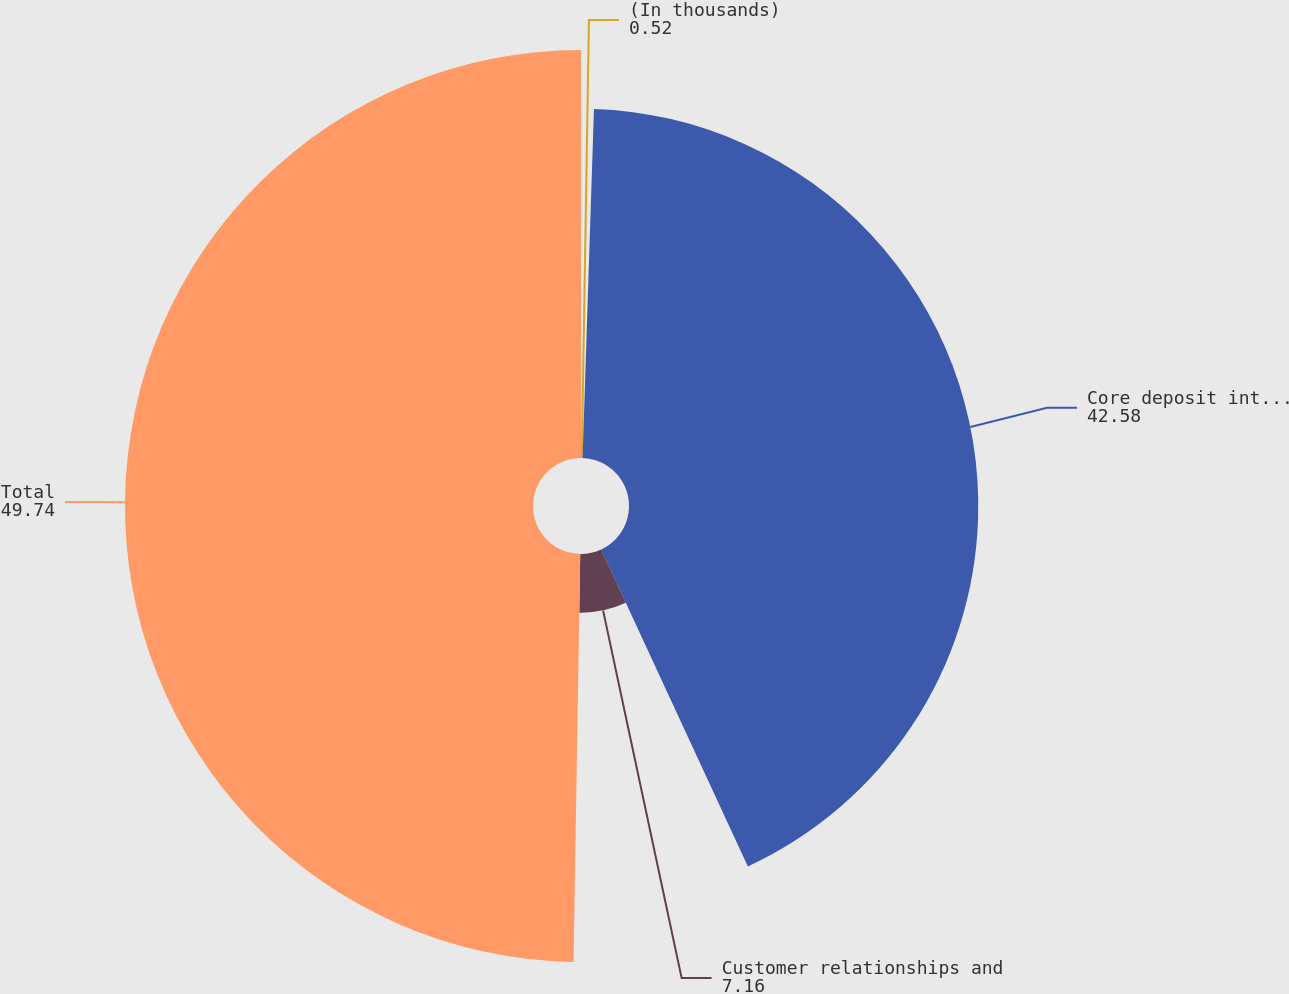Convert chart. <chart><loc_0><loc_0><loc_500><loc_500><pie_chart><fcel>(In thousands)<fcel>Core deposit intangibles<fcel>Customer relationships and<fcel>Total<nl><fcel>0.52%<fcel>42.58%<fcel>7.16%<fcel>49.74%<nl></chart> 